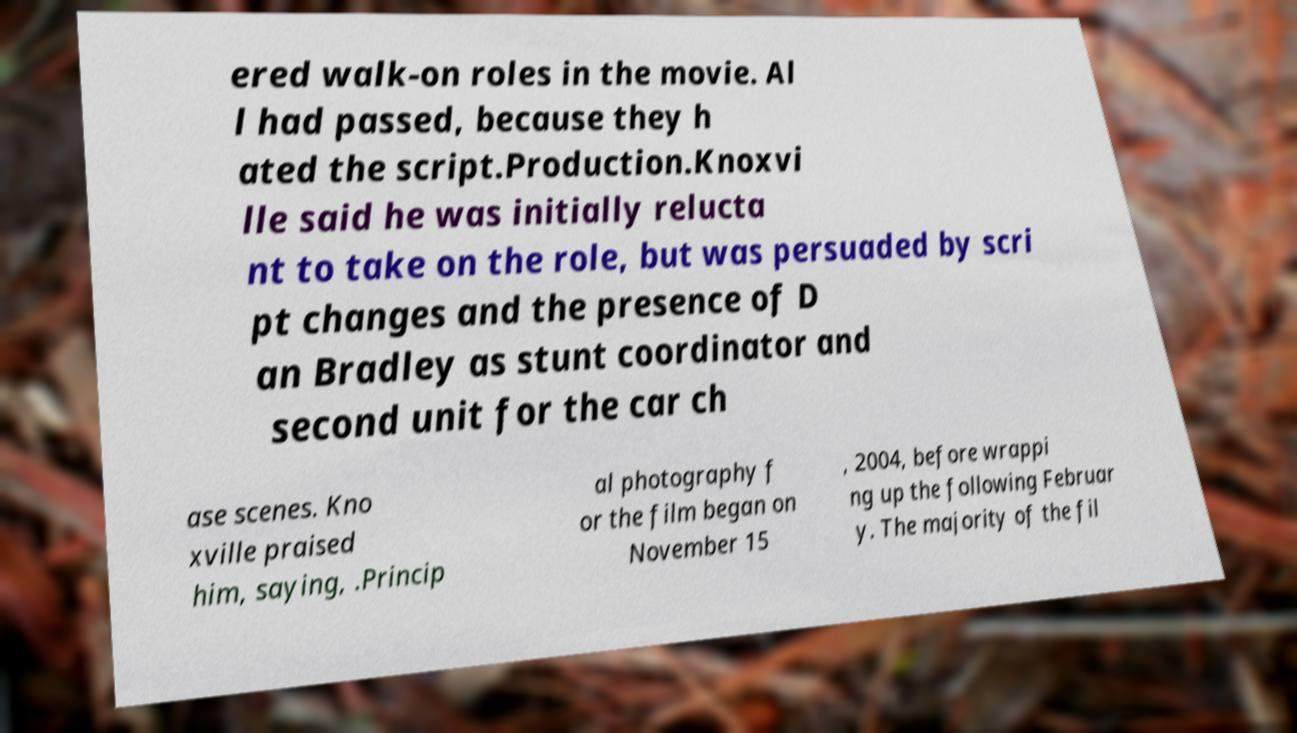Could you assist in decoding the text presented in this image and type it out clearly? ered walk-on roles in the movie. Al l had passed, because they h ated the script.Production.Knoxvi lle said he was initially relucta nt to take on the role, but was persuaded by scri pt changes and the presence of D an Bradley as stunt coordinator and second unit for the car ch ase scenes. Kno xville praised him, saying, .Princip al photography f or the film began on November 15 , 2004, before wrappi ng up the following Februar y. The majority of the fil 